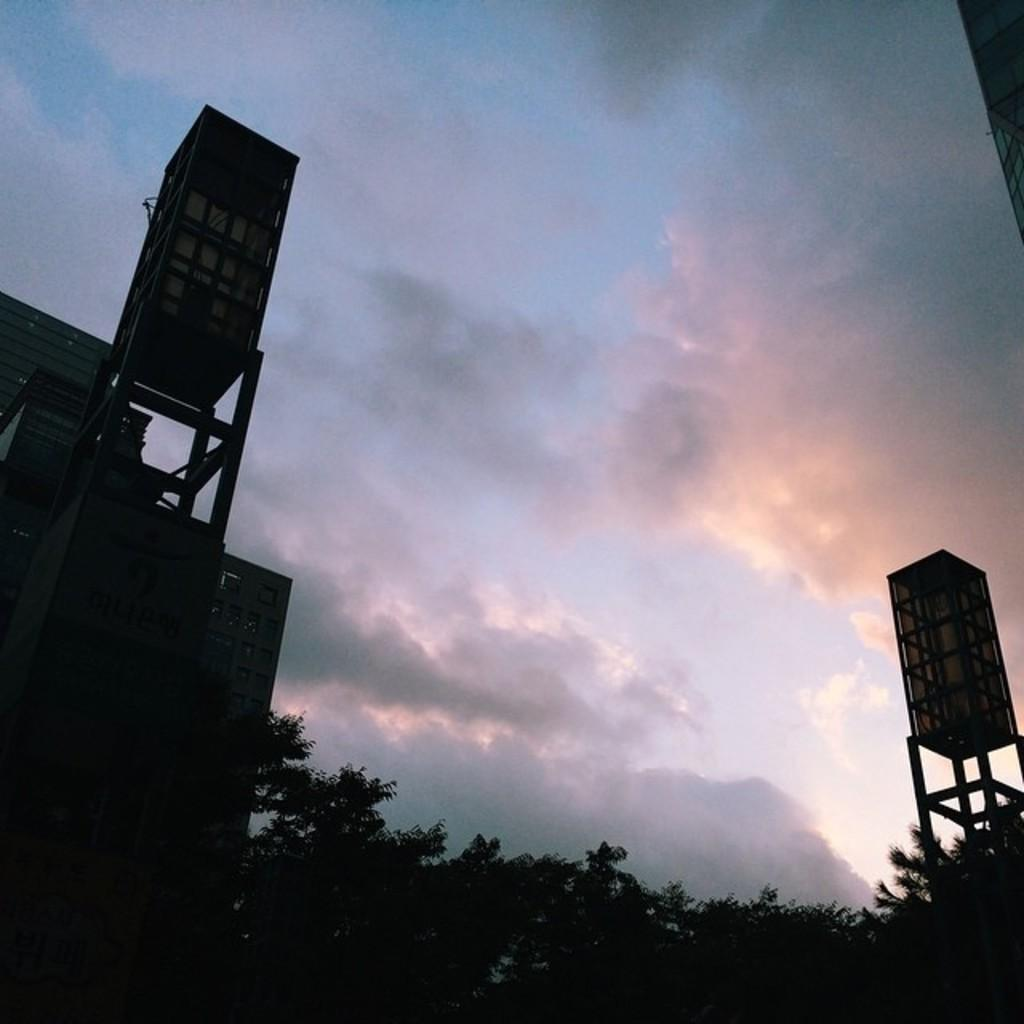What type of natural elements can be seen in the image? There are trees in the image. What type of man-made structures are present in the image? There are buildings and a tower in the image. What is the condition of the sky in the image? The sky is cloudy in the image. Are there any cows present in the amusement park depicted in the image? There is no amusement park depicted in the image, and no cows are present. What scale is used to represent the buildings in the image? The image does not provide information about the scale used to represent the buildings. 